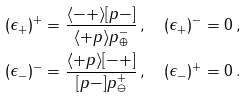<formula> <loc_0><loc_0><loc_500><loc_500>( \epsilon _ { + } ) ^ { + } & = \frac { \langle - + \rangle [ p - ] } { \langle + p \rangle p ^ { - } _ { \oplus } } \, , \quad ( \epsilon _ { + } ) ^ { - } = 0 \, , \\ ( \epsilon _ { - } ) ^ { - } & = \frac { \langle + p \rangle [ - + ] } { [ p - ] p ^ { + } _ { \ominus } } \, , \quad ( \epsilon _ { - } ) ^ { + } = 0 \, .</formula> 